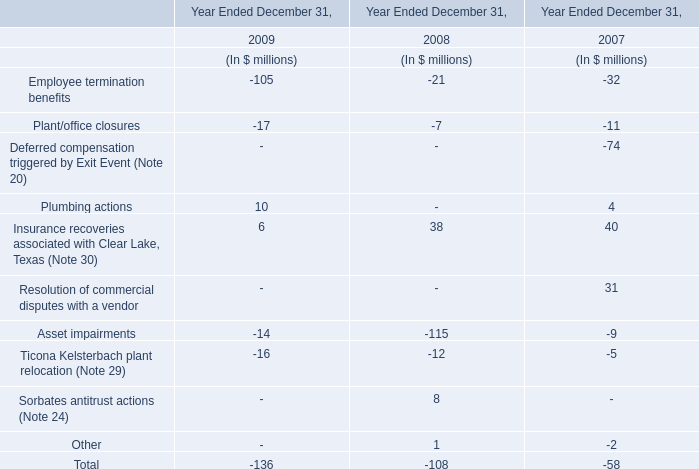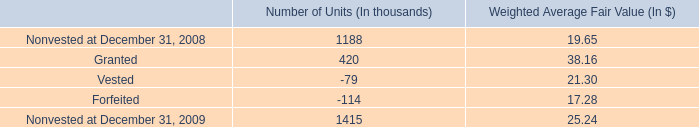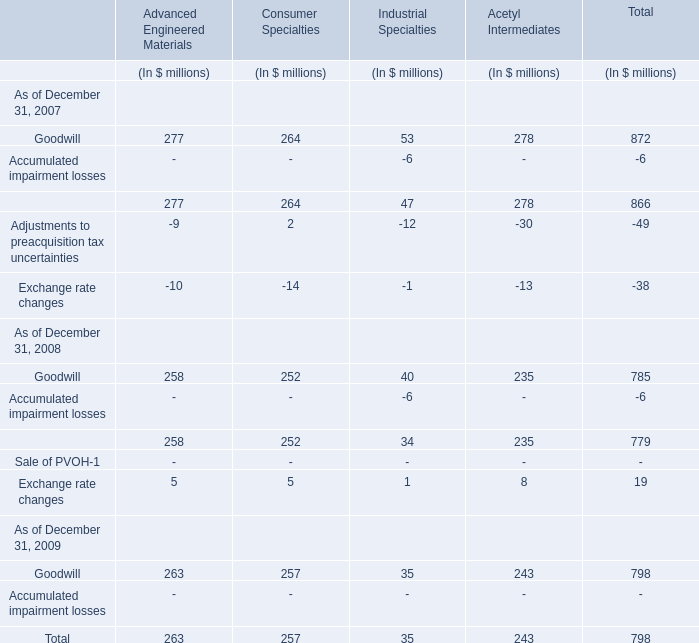What is the growing rate of Goodwill of Advanced Engineered Materialsin Table 2 in the years with the least Plant/office closures in Table 0? 
Computations: ((263 - 258) / 258)
Answer: 0.01938. 